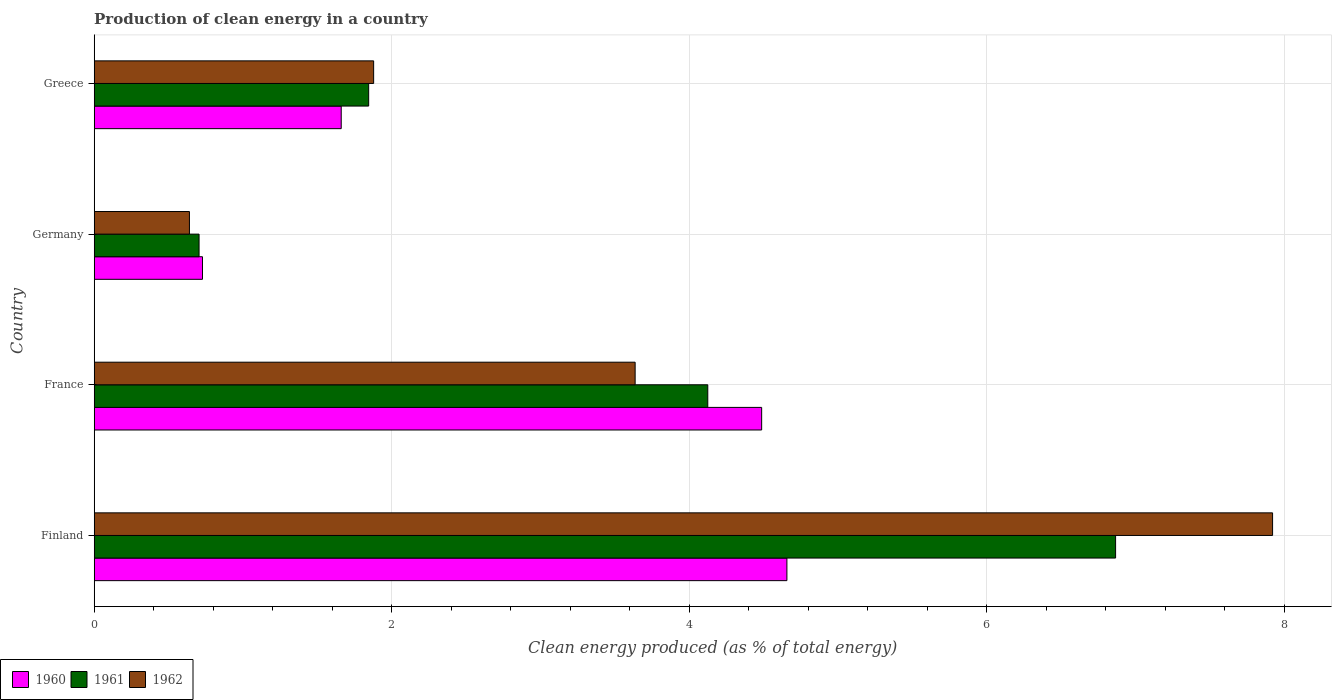Are the number of bars per tick equal to the number of legend labels?
Your answer should be compact. Yes. How many bars are there on the 4th tick from the bottom?
Ensure brevity in your answer.  3. What is the percentage of clean energy produced in 1960 in France?
Your answer should be compact. 4.49. Across all countries, what is the maximum percentage of clean energy produced in 1962?
Make the answer very short. 7.92. Across all countries, what is the minimum percentage of clean energy produced in 1962?
Make the answer very short. 0.64. In which country was the percentage of clean energy produced in 1960 minimum?
Make the answer very short. Germany. What is the total percentage of clean energy produced in 1960 in the graph?
Offer a very short reply. 11.53. What is the difference between the percentage of clean energy produced in 1961 in Finland and that in Germany?
Make the answer very short. 6.16. What is the difference between the percentage of clean energy produced in 1962 in Germany and the percentage of clean energy produced in 1961 in Finland?
Offer a terse response. -6.23. What is the average percentage of clean energy produced in 1962 per country?
Your answer should be compact. 3.52. What is the difference between the percentage of clean energy produced in 1961 and percentage of clean energy produced in 1960 in France?
Keep it short and to the point. -0.36. In how many countries, is the percentage of clean energy produced in 1961 greater than 4.4 %?
Keep it short and to the point. 1. What is the ratio of the percentage of clean energy produced in 1961 in Germany to that in Greece?
Offer a very short reply. 0.38. Is the percentage of clean energy produced in 1962 in Finland less than that in Greece?
Make the answer very short. No. Is the difference between the percentage of clean energy produced in 1961 in Finland and France greater than the difference between the percentage of clean energy produced in 1960 in Finland and France?
Give a very brief answer. Yes. What is the difference between the highest and the second highest percentage of clean energy produced in 1962?
Keep it short and to the point. 4.28. What is the difference between the highest and the lowest percentage of clean energy produced in 1961?
Ensure brevity in your answer.  6.16. What does the 2nd bar from the top in France represents?
Provide a succinct answer. 1961. How many countries are there in the graph?
Offer a very short reply. 4. What is the difference between two consecutive major ticks on the X-axis?
Give a very brief answer. 2. How many legend labels are there?
Make the answer very short. 3. What is the title of the graph?
Offer a terse response. Production of clean energy in a country. Does "2003" appear as one of the legend labels in the graph?
Provide a short and direct response. No. What is the label or title of the X-axis?
Ensure brevity in your answer.  Clean energy produced (as % of total energy). What is the label or title of the Y-axis?
Your answer should be very brief. Country. What is the Clean energy produced (as % of total energy) of 1960 in Finland?
Your answer should be compact. 4.66. What is the Clean energy produced (as % of total energy) in 1961 in Finland?
Offer a terse response. 6.87. What is the Clean energy produced (as % of total energy) in 1962 in Finland?
Make the answer very short. 7.92. What is the Clean energy produced (as % of total energy) of 1960 in France?
Your response must be concise. 4.49. What is the Clean energy produced (as % of total energy) of 1961 in France?
Make the answer very short. 4.12. What is the Clean energy produced (as % of total energy) of 1962 in France?
Make the answer very short. 3.64. What is the Clean energy produced (as % of total energy) in 1960 in Germany?
Your answer should be compact. 0.73. What is the Clean energy produced (as % of total energy) in 1961 in Germany?
Ensure brevity in your answer.  0.7. What is the Clean energy produced (as % of total energy) in 1962 in Germany?
Provide a short and direct response. 0.64. What is the Clean energy produced (as % of total energy) of 1960 in Greece?
Make the answer very short. 1.66. What is the Clean energy produced (as % of total energy) of 1961 in Greece?
Make the answer very short. 1.84. What is the Clean energy produced (as % of total energy) of 1962 in Greece?
Give a very brief answer. 1.88. Across all countries, what is the maximum Clean energy produced (as % of total energy) in 1960?
Your answer should be compact. 4.66. Across all countries, what is the maximum Clean energy produced (as % of total energy) in 1961?
Your answer should be compact. 6.87. Across all countries, what is the maximum Clean energy produced (as % of total energy) in 1962?
Make the answer very short. 7.92. Across all countries, what is the minimum Clean energy produced (as % of total energy) of 1960?
Offer a very short reply. 0.73. Across all countries, what is the minimum Clean energy produced (as % of total energy) in 1961?
Your answer should be very brief. 0.7. Across all countries, what is the minimum Clean energy produced (as % of total energy) of 1962?
Keep it short and to the point. 0.64. What is the total Clean energy produced (as % of total energy) of 1960 in the graph?
Your response must be concise. 11.53. What is the total Clean energy produced (as % of total energy) of 1961 in the graph?
Ensure brevity in your answer.  13.54. What is the total Clean energy produced (as % of total energy) in 1962 in the graph?
Your answer should be very brief. 14.08. What is the difference between the Clean energy produced (as % of total energy) in 1960 in Finland and that in France?
Keep it short and to the point. 0.17. What is the difference between the Clean energy produced (as % of total energy) of 1961 in Finland and that in France?
Your response must be concise. 2.74. What is the difference between the Clean energy produced (as % of total energy) in 1962 in Finland and that in France?
Keep it short and to the point. 4.28. What is the difference between the Clean energy produced (as % of total energy) of 1960 in Finland and that in Germany?
Keep it short and to the point. 3.93. What is the difference between the Clean energy produced (as % of total energy) in 1961 in Finland and that in Germany?
Keep it short and to the point. 6.16. What is the difference between the Clean energy produced (as % of total energy) of 1962 in Finland and that in Germany?
Your answer should be compact. 7.28. What is the difference between the Clean energy produced (as % of total energy) of 1960 in Finland and that in Greece?
Provide a short and direct response. 3. What is the difference between the Clean energy produced (as % of total energy) of 1961 in Finland and that in Greece?
Your answer should be compact. 5.02. What is the difference between the Clean energy produced (as % of total energy) of 1962 in Finland and that in Greece?
Your response must be concise. 6.04. What is the difference between the Clean energy produced (as % of total energy) of 1960 in France and that in Germany?
Your answer should be very brief. 3.76. What is the difference between the Clean energy produced (as % of total energy) of 1961 in France and that in Germany?
Give a very brief answer. 3.42. What is the difference between the Clean energy produced (as % of total energy) of 1962 in France and that in Germany?
Make the answer very short. 3. What is the difference between the Clean energy produced (as % of total energy) of 1960 in France and that in Greece?
Provide a succinct answer. 2.83. What is the difference between the Clean energy produced (as % of total energy) of 1961 in France and that in Greece?
Your answer should be very brief. 2.28. What is the difference between the Clean energy produced (as % of total energy) in 1962 in France and that in Greece?
Provide a succinct answer. 1.76. What is the difference between the Clean energy produced (as % of total energy) of 1960 in Germany and that in Greece?
Offer a very short reply. -0.93. What is the difference between the Clean energy produced (as % of total energy) in 1961 in Germany and that in Greece?
Your response must be concise. -1.14. What is the difference between the Clean energy produced (as % of total energy) of 1962 in Germany and that in Greece?
Your answer should be very brief. -1.24. What is the difference between the Clean energy produced (as % of total energy) in 1960 in Finland and the Clean energy produced (as % of total energy) in 1961 in France?
Your answer should be very brief. 0.53. What is the difference between the Clean energy produced (as % of total energy) of 1960 in Finland and the Clean energy produced (as % of total energy) of 1962 in France?
Offer a terse response. 1.02. What is the difference between the Clean energy produced (as % of total energy) of 1961 in Finland and the Clean energy produced (as % of total energy) of 1962 in France?
Provide a short and direct response. 3.23. What is the difference between the Clean energy produced (as % of total energy) of 1960 in Finland and the Clean energy produced (as % of total energy) of 1961 in Germany?
Your answer should be compact. 3.95. What is the difference between the Clean energy produced (as % of total energy) of 1960 in Finland and the Clean energy produced (as % of total energy) of 1962 in Germany?
Offer a very short reply. 4.02. What is the difference between the Clean energy produced (as % of total energy) in 1961 in Finland and the Clean energy produced (as % of total energy) in 1962 in Germany?
Provide a succinct answer. 6.23. What is the difference between the Clean energy produced (as % of total energy) in 1960 in Finland and the Clean energy produced (as % of total energy) in 1961 in Greece?
Keep it short and to the point. 2.81. What is the difference between the Clean energy produced (as % of total energy) of 1960 in Finland and the Clean energy produced (as % of total energy) of 1962 in Greece?
Make the answer very short. 2.78. What is the difference between the Clean energy produced (as % of total energy) of 1961 in Finland and the Clean energy produced (as % of total energy) of 1962 in Greece?
Offer a very short reply. 4.99. What is the difference between the Clean energy produced (as % of total energy) of 1960 in France and the Clean energy produced (as % of total energy) of 1961 in Germany?
Give a very brief answer. 3.78. What is the difference between the Clean energy produced (as % of total energy) in 1960 in France and the Clean energy produced (as % of total energy) in 1962 in Germany?
Your answer should be compact. 3.85. What is the difference between the Clean energy produced (as % of total energy) in 1961 in France and the Clean energy produced (as % of total energy) in 1962 in Germany?
Offer a terse response. 3.48. What is the difference between the Clean energy produced (as % of total energy) of 1960 in France and the Clean energy produced (as % of total energy) of 1961 in Greece?
Your response must be concise. 2.64. What is the difference between the Clean energy produced (as % of total energy) in 1960 in France and the Clean energy produced (as % of total energy) in 1962 in Greece?
Provide a short and direct response. 2.61. What is the difference between the Clean energy produced (as % of total energy) in 1961 in France and the Clean energy produced (as % of total energy) in 1962 in Greece?
Offer a very short reply. 2.25. What is the difference between the Clean energy produced (as % of total energy) of 1960 in Germany and the Clean energy produced (as % of total energy) of 1961 in Greece?
Offer a very short reply. -1.12. What is the difference between the Clean energy produced (as % of total energy) of 1960 in Germany and the Clean energy produced (as % of total energy) of 1962 in Greece?
Give a very brief answer. -1.15. What is the difference between the Clean energy produced (as % of total energy) in 1961 in Germany and the Clean energy produced (as % of total energy) in 1962 in Greece?
Offer a very short reply. -1.17. What is the average Clean energy produced (as % of total energy) in 1960 per country?
Your answer should be compact. 2.88. What is the average Clean energy produced (as % of total energy) of 1961 per country?
Keep it short and to the point. 3.38. What is the average Clean energy produced (as % of total energy) in 1962 per country?
Give a very brief answer. 3.52. What is the difference between the Clean energy produced (as % of total energy) in 1960 and Clean energy produced (as % of total energy) in 1961 in Finland?
Offer a very short reply. -2.21. What is the difference between the Clean energy produced (as % of total energy) in 1960 and Clean energy produced (as % of total energy) in 1962 in Finland?
Ensure brevity in your answer.  -3.26. What is the difference between the Clean energy produced (as % of total energy) in 1961 and Clean energy produced (as % of total energy) in 1962 in Finland?
Your answer should be very brief. -1.06. What is the difference between the Clean energy produced (as % of total energy) in 1960 and Clean energy produced (as % of total energy) in 1961 in France?
Your answer should be very brief. 0.36. What is the difference between the Clean energy produced (as % of total energy) in 1960 and Clean energy produced (as % of total energy) in 1962 in France?
Offer a terse response. 0.85. What is the difference between the Clean energy produced (as % of total energy) in 1961 and Clean energy produced (as % of total energy) in 1962 in France?
Your response must be concise. 0.49. What is the difference between the Clean energy produced (as % of total energy) of 1960 and Clean energy produced (as % of total energy) of 1961 in Germany?
Ensure brevity in your answer.  0.02. What is the difference between the Clean energy produced (as % of total energy) in 1960 and Clean energy produced (as % of total energy) in 1962 in Germany?
Give a very brief answer. 0.09. What is the difference between the Clean energy produced (as % of total energy) in 1961 and Clean energy produced (as % of total energy) in 1962 in Germany?
Give a very brief answer. 0.06. What is the difference between the Clean energy produced (as % of total energy) in 1960 and Clean energy produced (as % of total energy) in 1961 in Greece?
Offer a terse response. -0.18. What is the difference between the Clean energy produced (as % of total energy) of 1960 and Clean energy produced (as % of total energy) of 1962 in Greece?
Keep it short and to the point. -0.22. What is the difference between the Clean energy produced (as % of total energy) in 1961 and Clean energy produced (as % of total energy) in 1962 in Greece?
Your answer should be compact. -0.03. What is the ratio of the Clean energy produced (as % of total energy) in 1960 in Finland to that in France?
Offer a terse response. 1.04. What is the ratio of the Clean energy produced (as % of total energy) of 1961 in Finland to that in France?
Offer a very short reply. 1.66. What is the ratio of the Clean energy produced (as % of total energy) in 1962 in Finland to that in France?
Offer a very short reply. 2.18. What is the ratio of the Clean energy produced (as % of total energy) in 1960 in Finland to that in Germany?
Your answer should be compact. 6.4. What is the ratio of the Clean energy produced (as % of total energy) of 1961 in Finland to that in Germany?
Your answer should be very brief. 9.74. What is the ratio of the Clean energy produced (as % of total energy) of 1962 in Finland to that in Germany?
Give a very brief answer. 12.37. What is the ratio of the Clean energy produced (as % of total energy) of 1960 in Finland to that in Greece?
Your answer should be very brief. 2.8. What is the ratio of the Clean energy produced (as % of total energy) of 1961 in Finland to that in Greece?
Your answer should be very brief. 3.72. What is the ratio of the Clean energy produced (as % of total energy) in 1962 in Finland to that in Greece?
Make the answer very short. 4.22. What is the ratio of the Clean energy produced (as % of total energy) in 1960 in France to that in Germany?
Your response must be concise. 6.16. What is the ratio of the Clean energy produced (as % of total energy) of 1961 in France to that in Germany?
Ensure brevity in your answer.  5.85. What is the ratio of the Clean energy produced (as % of total energy) of 1962 in France to that in Germany?
Your answer should be compact. 5.68. What is the ratio of the Clean energy produced (as % of total energy) in 1960 in France to that in Greece?
Your answer should be very brief. 2.7. What is the ratio of the Clean energy produced (as % of total energy) of 1961 in France to that in Greece?
Make the answer very short. 2.24. What is the ratio of the Clean energy produced (as % of total energy) in 1962 in France to that in Greece?
Your answer should be very brief. 1.94. What is the ratio of the Clean energy produced (as % of total energy) of 1960 in Germany to that in Greece?
Offer a very short reply. 0.44. What is the ratio of the Clean energy produced (as % of total energy) in 1961 in Germany to that in Greece?
Offer a terse response. 0.38. What is the ratio of the Clean energy produced (as % of total energy) in 1962 in Germany to that in Greece?
Offer a terse response. 0.34. What is the difference between the highest and the second highest Clean energy produced (as % of total energy) in 1960?
Offer a very short reply. 0.17. What is the difference between the highest and the second highest Clean energy produced (as % of total energy) of 1961?
Ensure brevity in your answer.  2.74. What is the difference between the highest and the second highest Clean energy produced (as % of total energy) in 1962?
Make the answer very short. 4.28. What is the difference between the highest and the lowest Clean energy produced (as % of total energy) in 1960?
Your answer should be very brief. 3.93. What is the difference between the highest and the lowest Clean energy produced (as % of total energy) of 1961?
Your response must be concise. 6.16. What is the difference between the highest and the lowest Clean energy produced (as % of total energy) of 1962?
Your answer should be very brief. 7.28. 